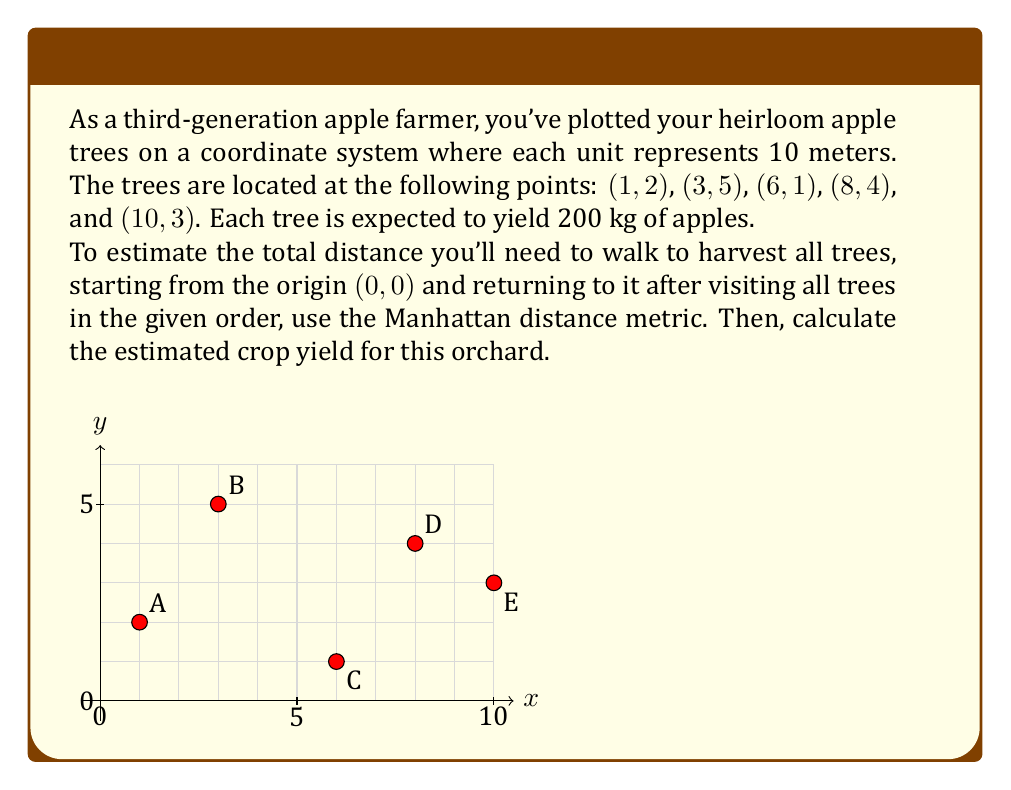Solve this math problem. Let's approach this step-by-step:

1) First, we need to calculate the Manhattan distance. The Manhattan distance between two points $(x_1, y_1)$ and $(x_2, y_2)$ is given by:

   $$|x_2 - x_1| + |y_2 - y_1|$$

2) Let's calculate the distances:
   - From (0,0) to (1,2): $|1-0| + |2-0| = 3$
   - From (1,2) to (3,5): $|3-1| + |5-2| = 5$
   - From (3,5) to (6,1): $|6-3| + |1-5| = 7$
   - From (6,1) to (8,4): $|8-6| + |4-1| = 5$
   - From (8,4) to (10,3): $|10-8| + |3-4| = 3$
   - From (10,3) back to (0,0): $|0-10| + |0-3| = 13$

3) Sum up all distances:
   $$3 + 5 + 7 + 5 + 3 + 13 = 36$$

4) Remember, each unit represents 10 meters, so the total distance is:
   $$36 * 10 = 360 \text{ meters}$$

5) For the crop yield, we have 5 trees, each yielding 200 kg:
   $$5 * 200 = 1000 \text{ kg}$$

Therefore, you'll walk 360 meters to harvest an estimated 1000 kg of apples.
Answer: 360 meters; 1000 kg 